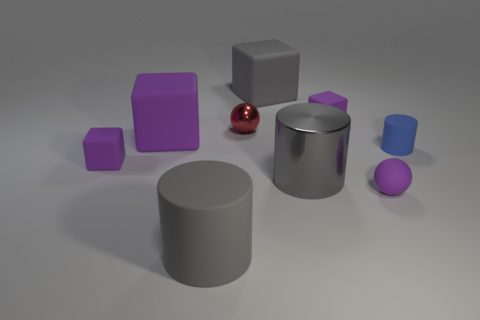Is the material of the purple thing that is behind the tiny red thing the same as the small ball left of the gray metallic cylinder? The purple object behind the small red sphere does not appear to be made of the same material as the smaller purple sphere to the left of the gray cylinder. The larger purple object has a matte finish, while the smaller purple sphere shares a reflective quality similar to the red sphere and the cylinder, suggesting that their materials have similar reflective properties. 